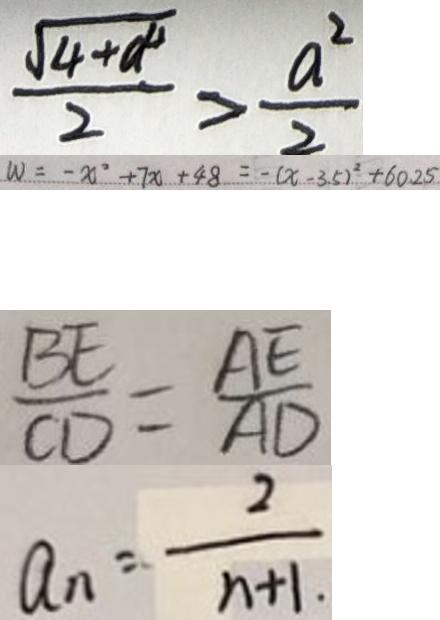Convert formula to latex. <formula><loc_0><loc_0><loc_500><loc_500>\frac { \sqrt { 4 + a ^ { 4 } } } { 2 } > \frac { a ^ { 2 } } { 2 } 
 W = - x ^ { 2 } + 7 x + 4 8 = - ( x - 3 . 5 ) ^ { 2 } + 6 0 . 2 5 
 \frac { B E } { C D } = \frac { A E } { A D } 
 a _ { n } = \frac { 2 } { n + 1 }</formula> 